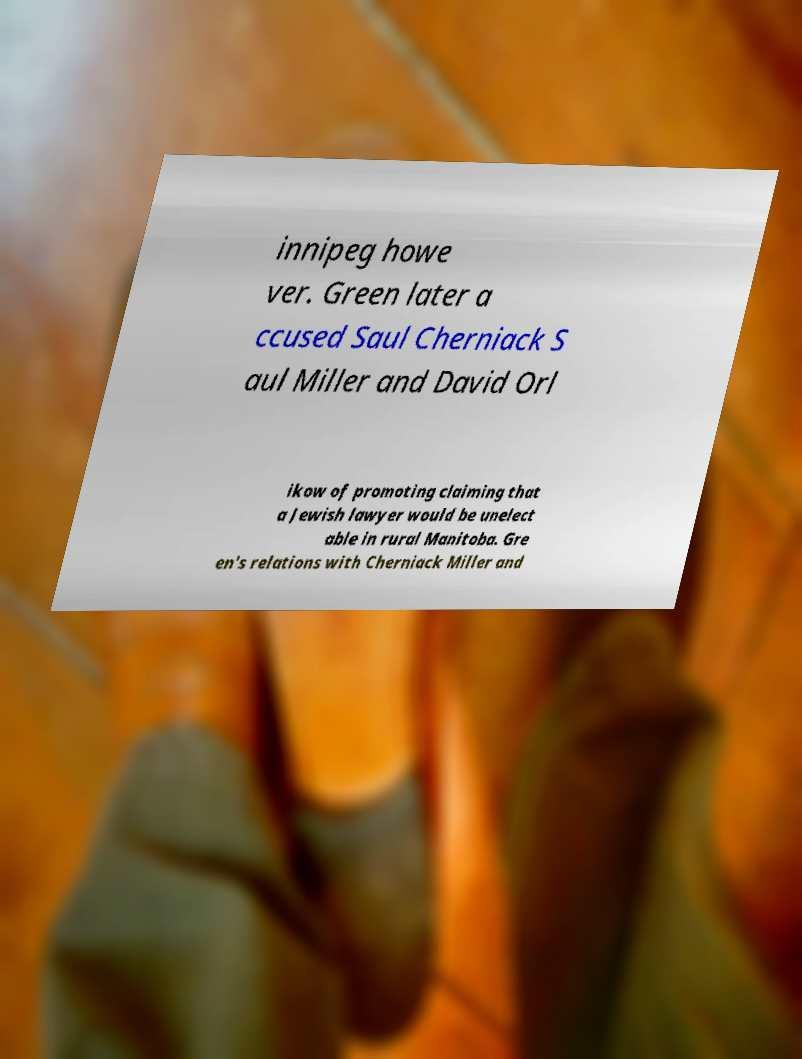Can you read and provide the text displayed in the image?This photo seems to have some interesting text. Can you extract and type it out for me? innipeg howe ver. Green later a ccused Saul Cherniack S aul Miller and David Orl ikow of promoting claiming that a Jewish lawyer would be unelect able in rural Manitoba. Gre en's relations with Cherniack Miller and 